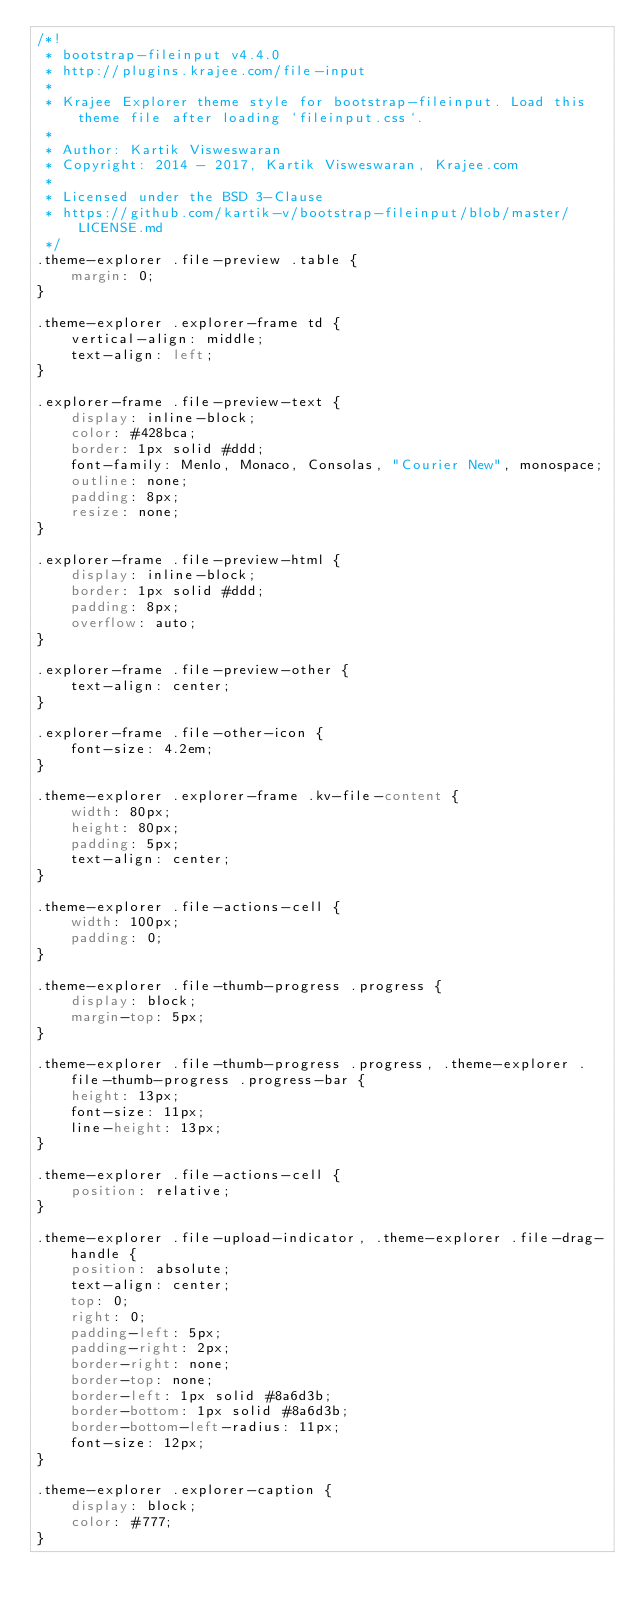<code> <loc_0><loc_0><loc_500><loc_500><_CSS_>/*!
 * bootstrap-fileinput v4.4.0
 * http://plugins.krajee.com/file-input
 *
 * Krajee Explorer theme style for bootstrap-fileinput. Load this theme file after loading `fileinput.css`.
 *
 * Author: Kartik Visweswaran
 * Copyright: 2014 - 2017, Kartik Visweswaran, Krajee.com
 *
 * Licensed under the BSD 3-Clause
 * https://github.com/kartik-v/bootstrap-fileinput/blob/master/LICENSE.md
 */
.theme-explorer .file-preview .table {
    margin: 0;
}

.theme-explorer .explorer-frame td {
    vertical-align: middle;
    text-align: left;
}

.explorer-frame .file-preview-text {
    display: inline-block;
    color: #428bca;
    border: 1px solid #ddd;
    font-family: Menlo, Monaco, Consolas, "Courier New", monospace;
    outline: none;
    padding: 8px;
    resize: none;
}

.explorer-frame .file-preview-html {
    display: inline-block;
    border: 1px solid #ddd;
    padding: 8px;
    overflow: auto;
}

.explorer-frame .file-preview-other {
    text-align: center;
}

.explorer-frame .file-other-icon {
    font-size: 4.2em;
}

.theme-explorer .explorer-frame .kv-file-content {
    width: 80px;
    height: 80px;
    padding: 5px;
    text-align: center;
}

.theme-explorer .file-actions-cell {
    width: 100px;
    padding: 0;
}

.theme-explorer .file-thumb-progress .progress {
    display: block;
    margin-top: 5px;
}

.theme-explorer .file-thumb-progress .progress, .theme-explorer .file-thumb-progress .progress-bar {
    height: 13px;
    font-size: 11px;
    line-height: 13px;
}

.theme-explorer .file-actions-cell {
    position: relative;
}

.theme-explorer .file-upload-indicator, .theme-explorer .file-drag-handle {
    position: absolute;
    text-align: center;
    top: 0;
    right: 0;
    padding-left: 5px;
    padding-right: 2px;
    border-right: none;
    border-top: none;
    border-left: 1px solid #8a6d3b;
    border-bottom: 1px solid #8a6d3b;
    border-bottom-left-radius: 11px;
    font-size: 12px;
}

.theme-explorer .explorer-caption {
    display: block;
    color: #777;
}
</code> 